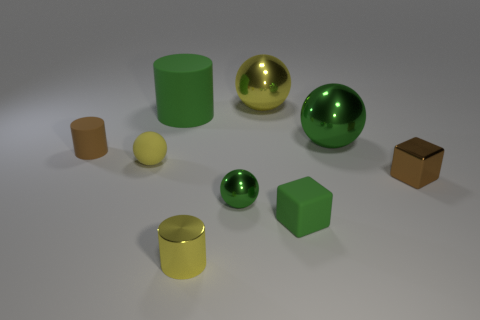Subtract all green rubber cylinders. How many cylinders are left? 2 Subtract 3 balls. How many balls are left? 1 Subtract all brown blocks. How many blocks are left? 1 Subtract all blocks. How many objects are left? 7 Subtract all tiny yellow metallic objects. Subtract all green rubber objects. How many objects are left? 6 Add 7 small green objects. How many small green objects are left? 9 Add 7 tiny yellow rubber things. How many tiny yellow rubber things exist? 8 Subtract 1 brown cylinders. How many objects are left? 8 Subtract all cyan balls. Subtract all cyan cylinders. How many balls are left? 4 Subtract all purple cylinders. How many blue cubes are left? 0 